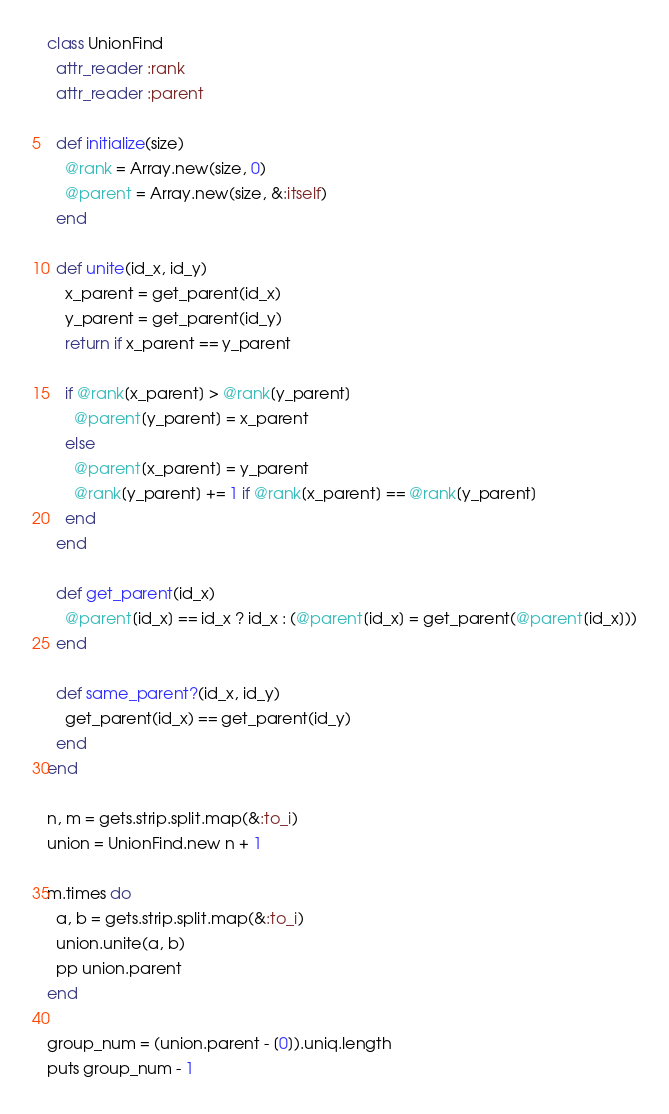Convert code to text. <code><loc_0><loc_0><loc_500><loc_500><_Ruby_>class UnionFind
  attr_reader :rank
  attr_reader :parent

  def initialize(size)
    @rank = Array.new(size, 0)
    @parent = Array.new(size, &:itself)
  end

  def unite(id_x, id_y)
    x_parent = get_parent(id_x)
    y_parent = get_parent(id_y)
    return if x_parent == y_parent

    if @rank[x_parent] > @rank[y_parent]
      @parent[y_parent] = x_parent
    else
      @parent[x_parent] = y_parent
      @rank[y_parent] += 1 if @rank[x_parent] == @rank[y_parent]
    end
  end

  def get_parent(id_x)
    @parent[id_x] == id_x ? id_x : (@parent[id_x] = get_parent(@parent[id_x]))
  end

  def same_parent?(id_x, id_y)
    get_parent(id_x) == get_parent(id_y)
  end
end

n, m = gets.strip.split.map(&:to_i)
union = UnionFind.new n + 1

m.times do
  a, b = gets.strip.split.map(&:to_i)
  union.unite(a, b)
  pp union.parent
end

group_num = (union.parent - [0]).uniq.length
puts group_num - 1
</code> 